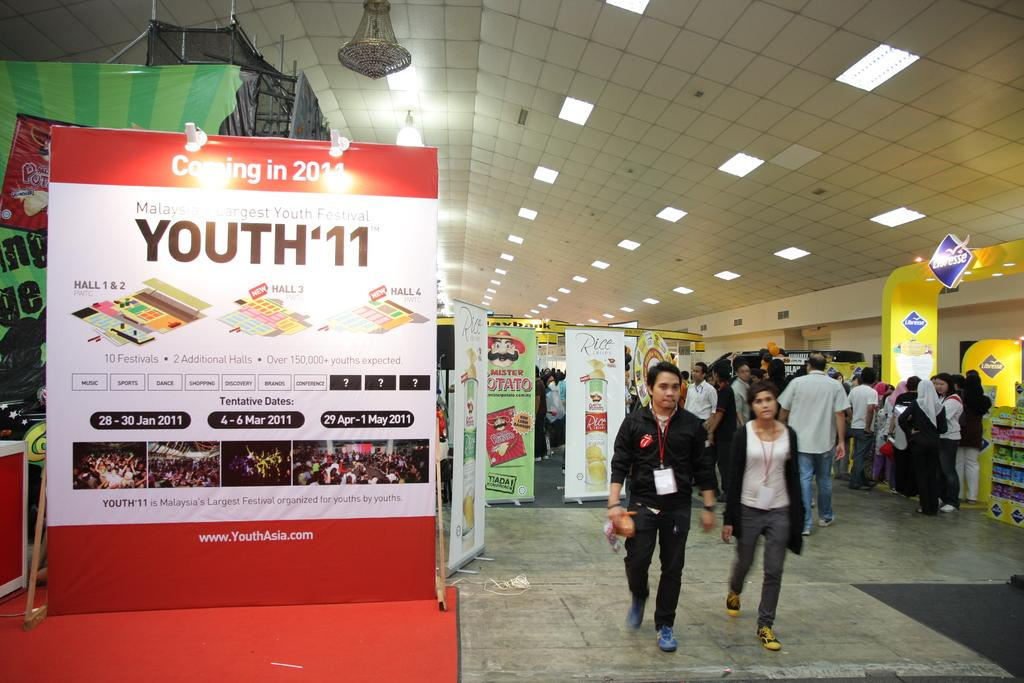<image>
Give a short and clear explanation of the subsequent image. People walking next to a sign that says Youth 11. 